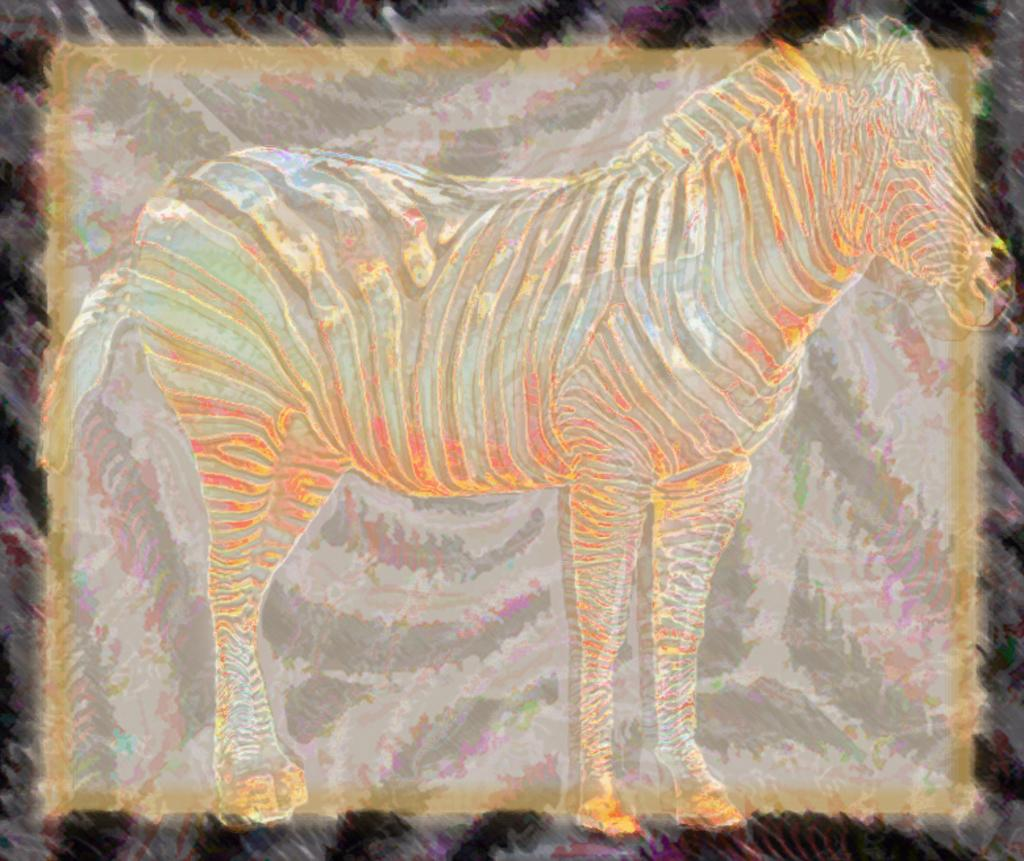What animal is present in the image? There is a zebra in the image. What is unique about the zebra's appearance? The zebra is in different colors. What time of day is it in the image, according to the hour? There is no indication of time in the image, so it is not possible to determine the hour. 